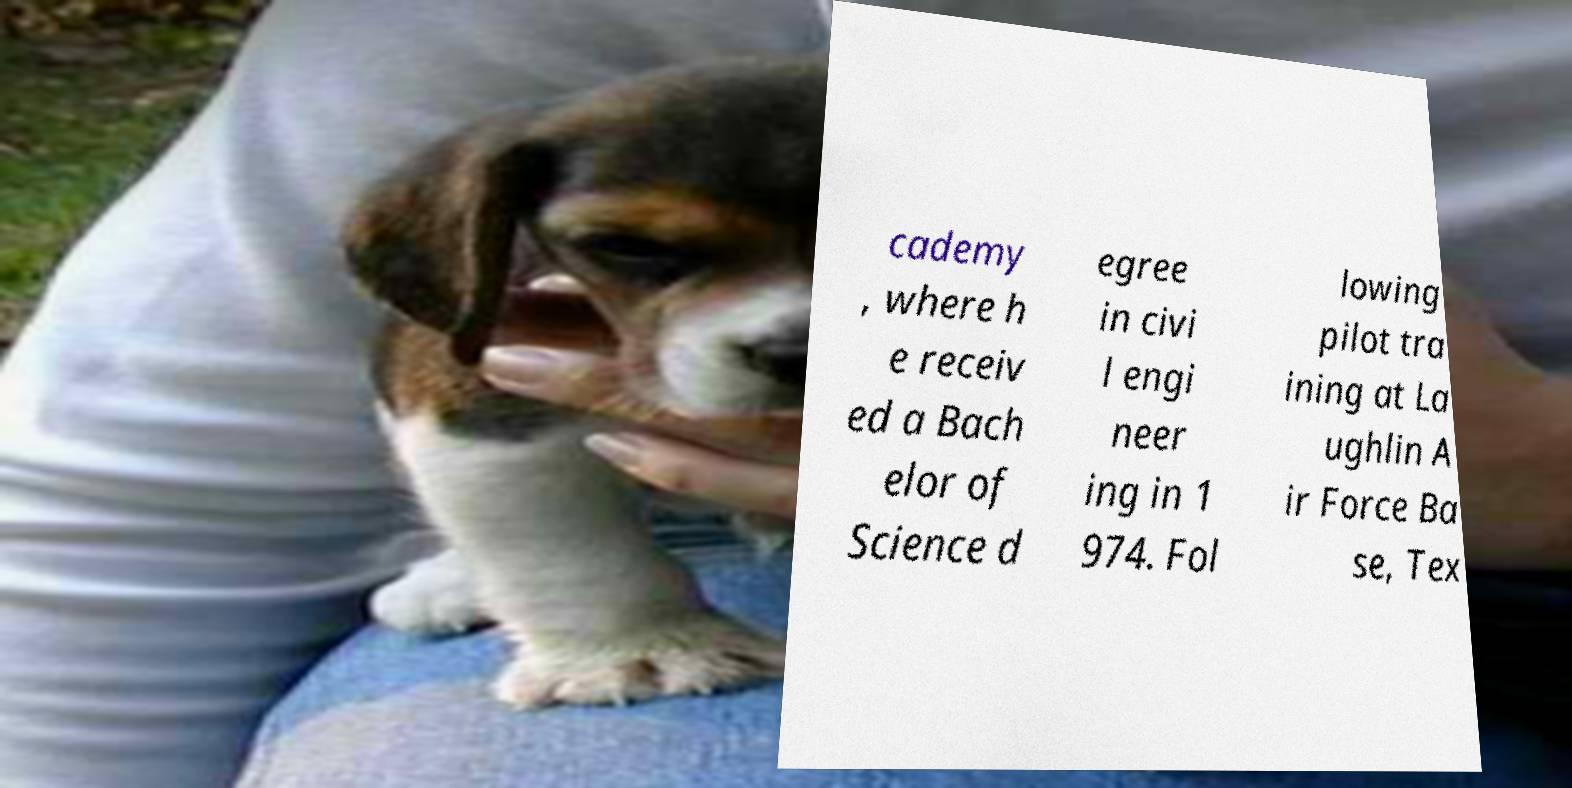There's text embedded in this image that I need extracted. Can you transcribe it verbatim? cademy , where h e receiv ed a Bach elor of Science d egree in civi l engi neer ing in 1 974. Fol lowing pilot tra ining at La ughlin A ir Force Ba se, Tex 